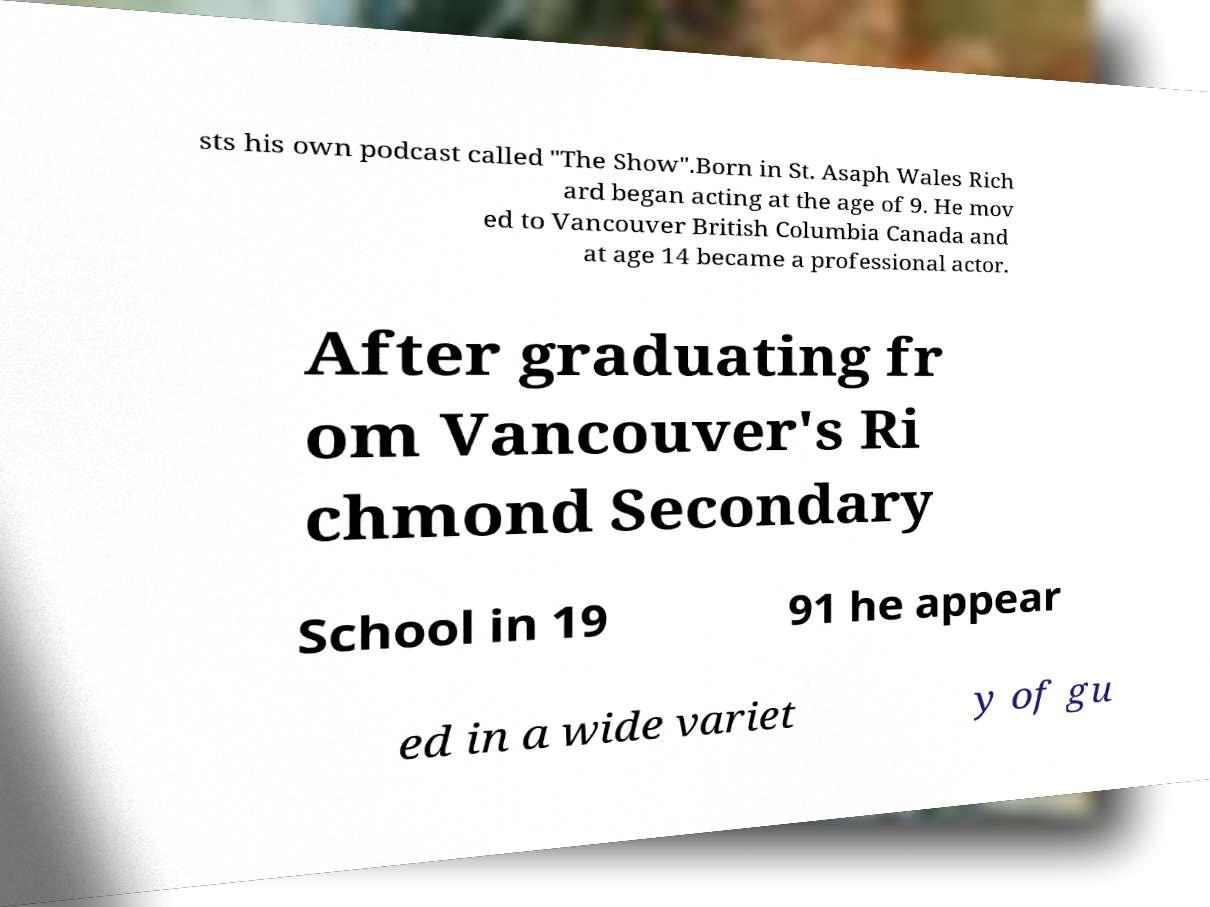I need the written content from this picture converted into text. Can you do that? sts his own podcast called "The Show".Born in St. Asaph Wales Rich ard began acting at the age of 9. He mov ed to Vancouver British Columbia Canada and at age 14 became a professional actor. After graduating fr om Vancouver's Ri chmond Secondary School in 19 91 he appear ed in a wide variet y of gu 